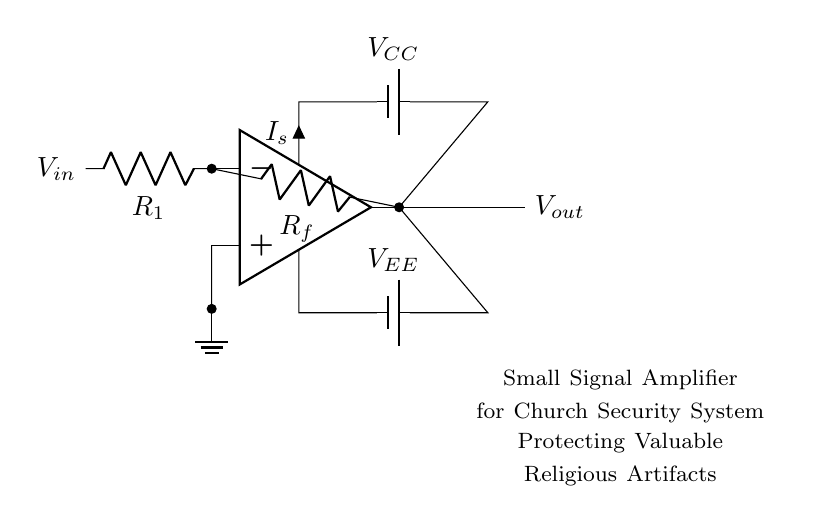What type of amplifier is shown? The circuit diagram features a small signal amplifier, as indicated by the label directly on the circuit.
Answer: small signal amplifier What is the purpose of the resistors labeled R1 and Rf? Resistor R1 is used to set the input impedance and Rf is the feedback resistor that sets the gain of the amplifier.
Answer: setting gain What is the power supply voltage indicated in the diagram? The voltages labeled as VCC and VEE in the diagram show the positive and negative supply voltages for the op-amp circuit.
Answer: VCC and VEE How many power supply connections does this amplifier have? The diagram indicates two power supply connections: one for VCC and one for VEE, which provide the necessary voltage for the amplifier.
Answer: two What is the significance of the ground connection in this circuit? The ground connection serves as a reference point for all other voltages in the circuit, ensuring stable operation of the amplifier.
Answer: reference point What type of output does this circuit provide? The output from the op-amp, indicated as Vout, is an amplified version of the input signal Vin, reinforcing the purpose of the amplifier.
Answer: amplified output What is the function of the op-amp in this circuit? The operational amplifier amplifies the input signal, which is a critical feature of the small signal amplifier for enhancing the signal of interest.
Answer: amplify input signal 